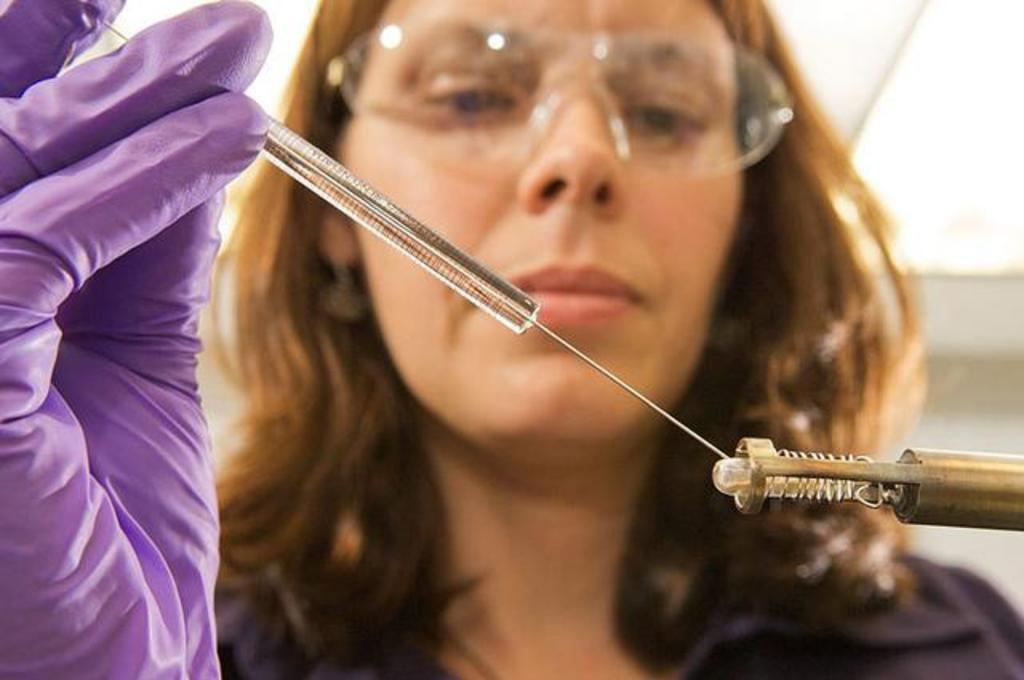Who is present in the image? There is a woman in the image. What is the woman wearing on her face? The woman is wearing spectacles. What is the woman holding in her hand? The woman is holding an injection. What is the woman wearing on her hand? The woman is wearing a glove on her hand. What can be seen on the right side of the image? There is an object on the right side of the image. What type of coil is the kitty playing with in the image? There is no kitty or coil present in the image. How does the woman help the person coughing in the image? There is no indication of a person coughing in the image. 